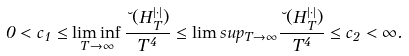Convert formula to latex. <formula><loc_0><loc_0><loc_500><loc_500>0 < c _ { 1 } \leq \liminf _ { T \to \infty } \frac { \lambda ( H ^ { | \cdot | } _ { T } ) } { T ^ { 4 } } \leq \lim s u p _ { T \to \infty } \frac { \lambda ( H ^ { | \cdot | } _ { T } ) } { T ^ { 4 } } \leq c _ { 2 } < \infty .</formula> 